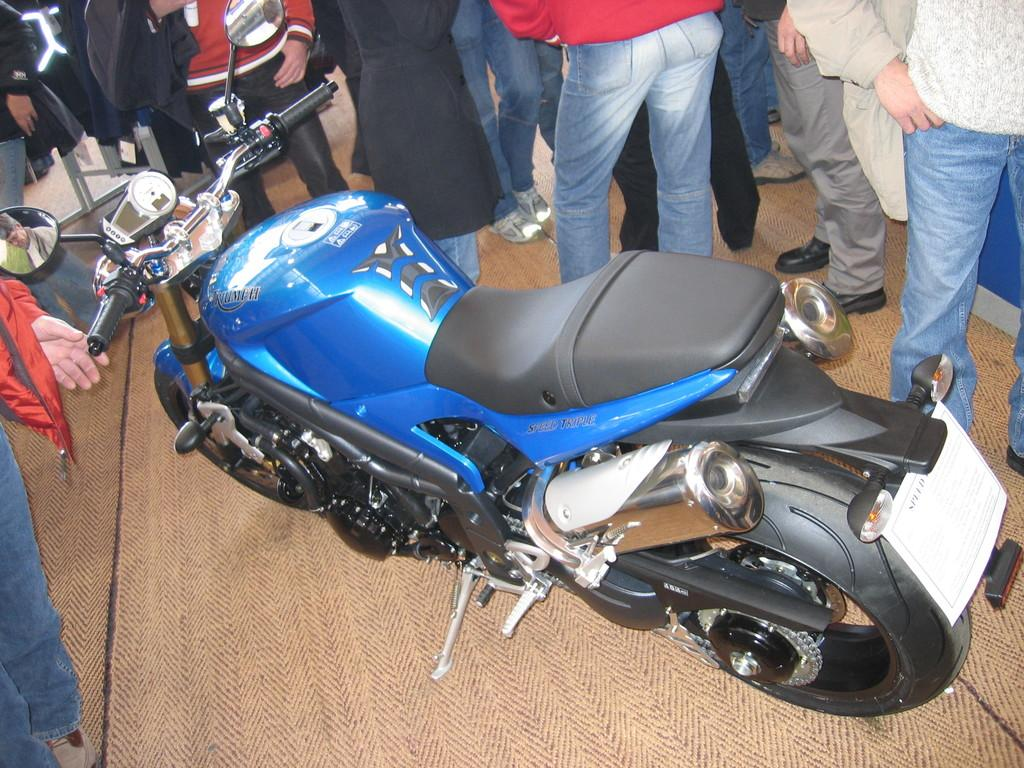What object is on the floor in the image? There is a bike on the floor in the image. Can you describe any other elements in the image? Legs of persons are visible in the image. What type of noise can be heard coming from the letter in the image? There is no letter present in the image, and therefore no noise can be heard from it. 